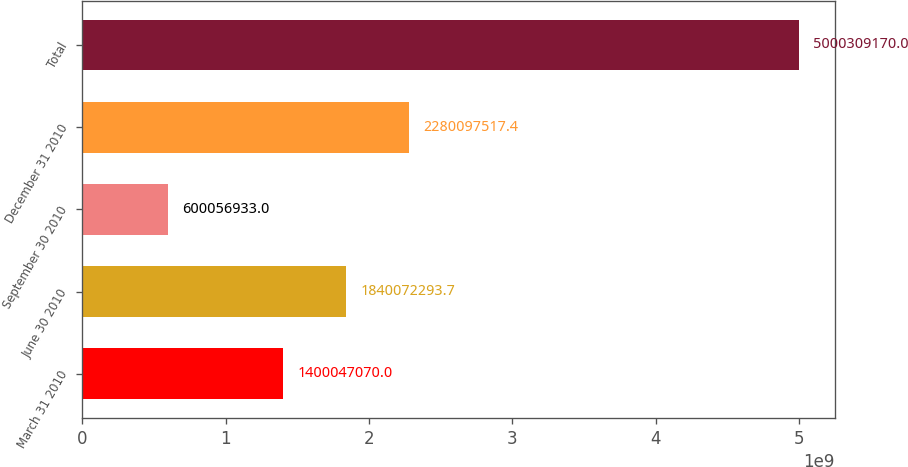Convert chart. <chart><loc_0><loc_0><loc_500><loc_500><bar_chart><fcel>March 31 2010<fcel>June 30 2010<fcel>September 30 2010<fcel>December 31 2010<fcel>Total<nl><fcel>1.40005e+09<fcel>1.84007e+09<fcel>6.00057e+08<fcel>2.2801e+09<fcel>5.00031e+09<nl></chart> 